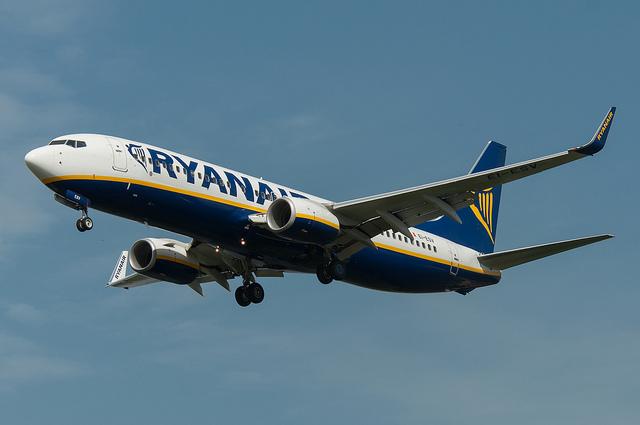Is the landing gear down?
Give a very brief answer. Yes. What color is the plane?
Write a very short answer. White, blue, yellow. What color is the top stripe on the plane?
Be succinct. Yellow. 